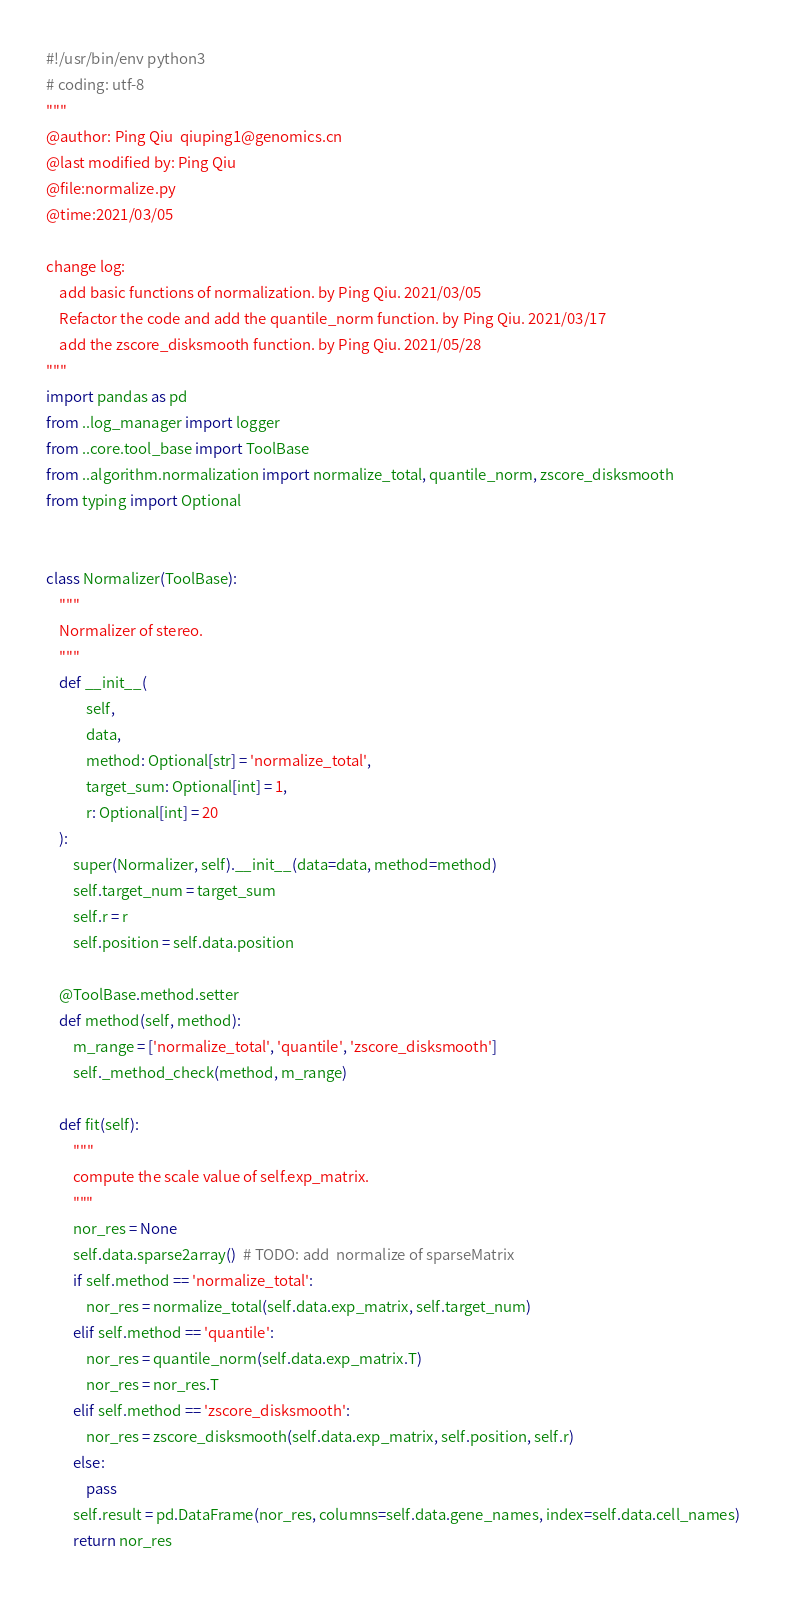<code> <loc_0><loc_0><loc_500><loc_500><_Python_>#!/usr/bin/env python3
# coding: utf-8
"""
@author: Ping Qiu  qiuping1@genomics.cn
@last modified by: Ping Qiu
@file:normalize.py
@time:2021/03/05

change log:
    add basic functions of normalization. by Ping Qiu. 2021/03/05
    Refactor the code and add the quantile_norm function. by Ping Qiu. 2021/03/17
    add the zscore_disksmooth function. by Ping Qiu. 2021/05/28
"""
import pandas as pd
from ..log_manager import logger
from ..core.tool_base import ToolBase
from ..algorithm.normalization import normalize_total, quantile_norm, zscore_disksmooth
from typing import Optional


class Normalizer(ToolBase):
    """
    Normalizer of stereo.
    """
    def __init__(
            self,
            data,
            method: Optional[str] = 'normalize_total',
            target_sum: Optional[int] = 1,
            r: Optional[int] = 20
    ):
        super(Normalizer, self).__init__(data=data, method=method)
        self.target_num = target_sum
        self.r = r
        self.position = self.data.position

    @ToolBase.method.setter
    def method(self, method):
        m_range = ['normalize_total', 'quantile', 'zscore_disksmooth']
        self._method_check(method, m_range)

    def fit(self):
        """
        compute the scale value of self.exp_matrix.
        """
        nor_res = None
        self.data.sparse2array()  # TODO: add  normalize of sparseMatrix
        if self.method == 'normalize_total':
            nor_res = normalize_total(self.data.exp_matrix, self.target_num)
        elif self.method == 'quantile':
            nor_res = quantile_norm(self.data.exp_matrix.T)
            nor_res = nor_res.T
        elif self.method == 'zscore_disksmooth':
            nor_res = zscore_disksmooth(self.data.exp_matrix, self.position, self.r)
        else:
            pass
        self.result = pd.DataFrame(nor_res, columns=self.data.gene_names, index=self.data.cell_names)
        return nor_res
</code> 